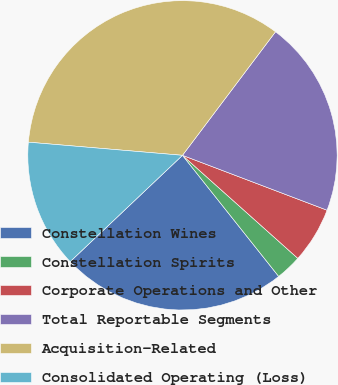<chart> <loc_0><loc_0><loc_500><loc_500><pie_chart><fcel>Constellation Wines<fcel>Constellation Spirits<fcel>Corporate Operations and Other<fcel>Total Reportable Segments<fcel>Acquisition-Related<fcel>Consolidated Operating (Loss)<nl><fcel>23.62%<fcel>2.71%<fcel>5.83%<fcel>20.5%<fcel>33.92%<fcel>13.42%<nl></chart> 